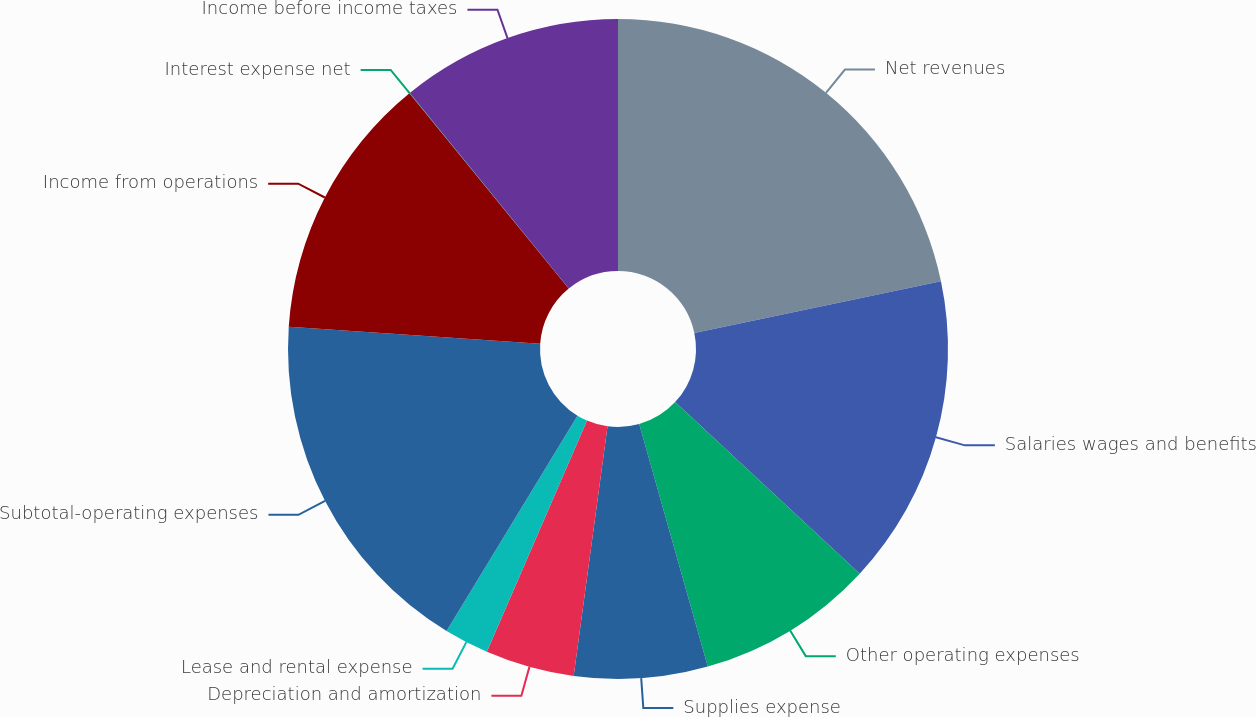<chart> <loc_0><loc_0><loc_500><loc_500><pie_chart><fcel>Net revenues<fcel>Salaries wages and benefits<fcel>Other operating expenses<fcel>Supplies expense<fcel>Depreciation and amortization<fcel>Lease and rental expense<fcel>Subtotal-operating expenses<fcel>Income from operations<fcel>Interest expense net<fcel>Income before income taxes<nl><fcel>21.71%<fcel>15.21%<fcel>8.7%<fcel>6.53%<fcel>4.36%<fcel>2.19%<fcel>17.38%<fcel>13.04%<fcel>0.02%<fcel>10.87%<nl></chart> 